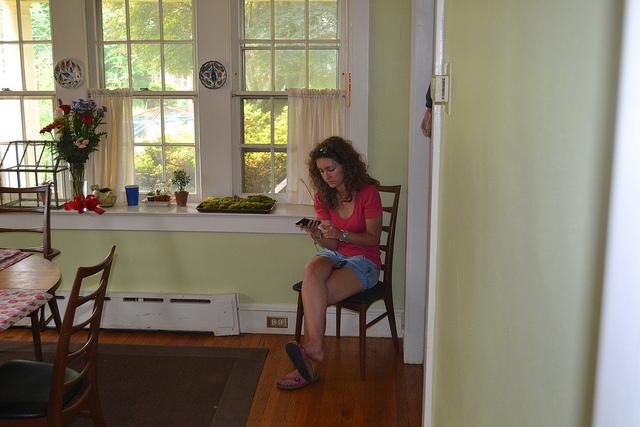What kind of flowers are in the pot?
Concise answer only. Roses. How many cats are sitting on the windowsill?
Answer briefly. 0. How many people are in the kitchen?
Short answer required. 1. What is the woman looking at?
Write a very short answer. Phone. Is the woman lying in sunlight?
Keep it brief. No. Is the woman on the right wearing a cap?
Short answer required. No. What color is the chair cushion?
Short answer required. Black. What kind of heating system is used in this room?
Quick response, please. Electric. How many windows are open?
Concise answer only. 0. What is the woman sitting on?
Answer briefly. Chair. Is this through a window?
Quick response, please. No. Is it sunny?
Quick response, please. Yes. What time of day is this picture taken?
Keep it brief. Afternoon. Is it a nice day outside?
Short answer required. Yes. Is that stool real wood?
Answer briefly. Yes. Is the woman angry?
Answer briefly. No. Is the cord to the blow dryer visible in the picture?
Quick response, please. No. Is this room esthetically pleasing?
Be succinct. Yes. What color is the back of each chair?
Short answer required. Brown. Is there a ball on the floor?
Give a very brief answer. No. Is the woman wearing short shorts?
Answer briefly. Yes. What are the people watching?
Keep it brief. Phone. How many people are in the room?
Keep it brief. 1. Is there an ocean in the photo?
Answer briefly. No. Is the person texting?
Write a very short answer. Yes. Is she ready to hit the ball?
Concise answer only. No. Is the room clean?
Quick response, please. Yes. What is the floor made of?
Write a very short answer. Wood. 